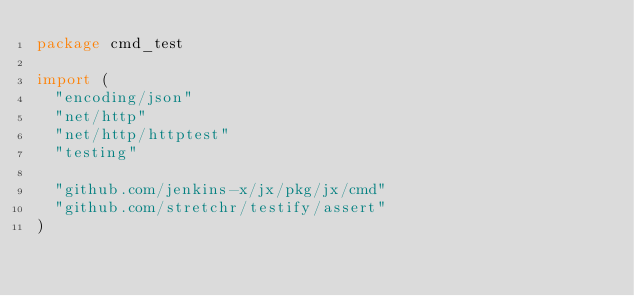<code> <loc_0><loc_0><loc_500><loc_500><_Go_>package cmd_test

import (
	"encoding/json"
	"net/http"
	"net/http/httptest"
	"testing"

	"github.com/jenkins-x/jx/pkg/jx/cmd"
	"github.com/stretchr/testify/assert"
)
</code> 